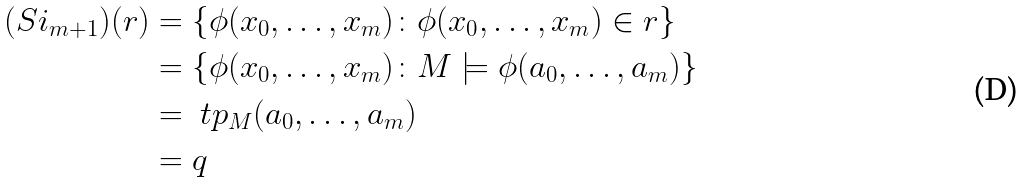<formula> <loc_0><loc_0><loc_500><loc_500>( S i _ { m + 1 } ) ( r ) & = \{ \phi ( x _ { 0 } , \dots , x _ { m } ) \colon \phi ( x _ { 0 } , \dots , x _ { m } ) \in r \} \\ & = \{ \phi ( x _ { 0 } , \dots , x _ { m } ) \colon M \models \phi ( a _ { 0 } , \dots , a _ { m } ) \} \\ & = \ t p _ { M } ( a _ { 0 } , \dots , a _ { m } ) \\ & = q</formula> 